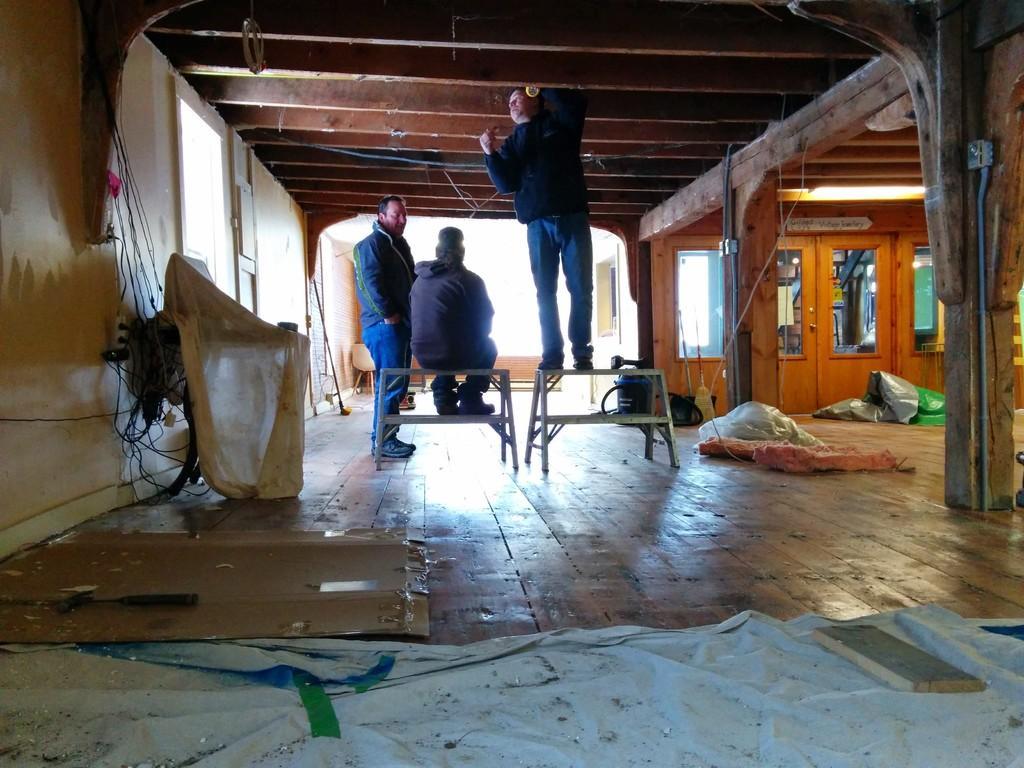In one or two sentences, can you explain what this image depicts? In this picture I can observe three men in the middle of the picture. On the right side I can observe doors. On the left side I can observe wall. 